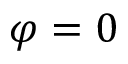Convert formula to latex. <formula><loc_0><loc_0><loc_500><loc_500>\varphi = 0</formula> 